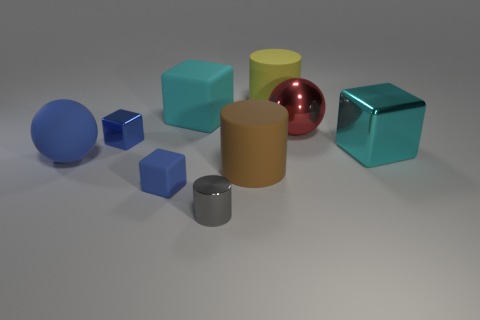Subtract all blue metal blocks. How many blocks are left? 3 Subtract 2 cylinders. How many cylinders are left? 1 Subtract all brown blocks. Subtract all blue cylinders. How many blocks are left? 4 Subtract all red blocks. How many gray spheres are left? 0 Subtract all yellow balls. Subtract all big blocks. How many objects are left? 7 Add 6 tiny blue blocks. How many tiny blue blocks are left? 8 Add 3 tiny gray shiny cylinders. How many tiny gray shiny cylinders exist? 4 Subtract all blue spheres. How many spheres are left? 1 Subtract 1 gray cylinders. How many objects are left? 8 Subtract all cubes. How many objects are left? 5 